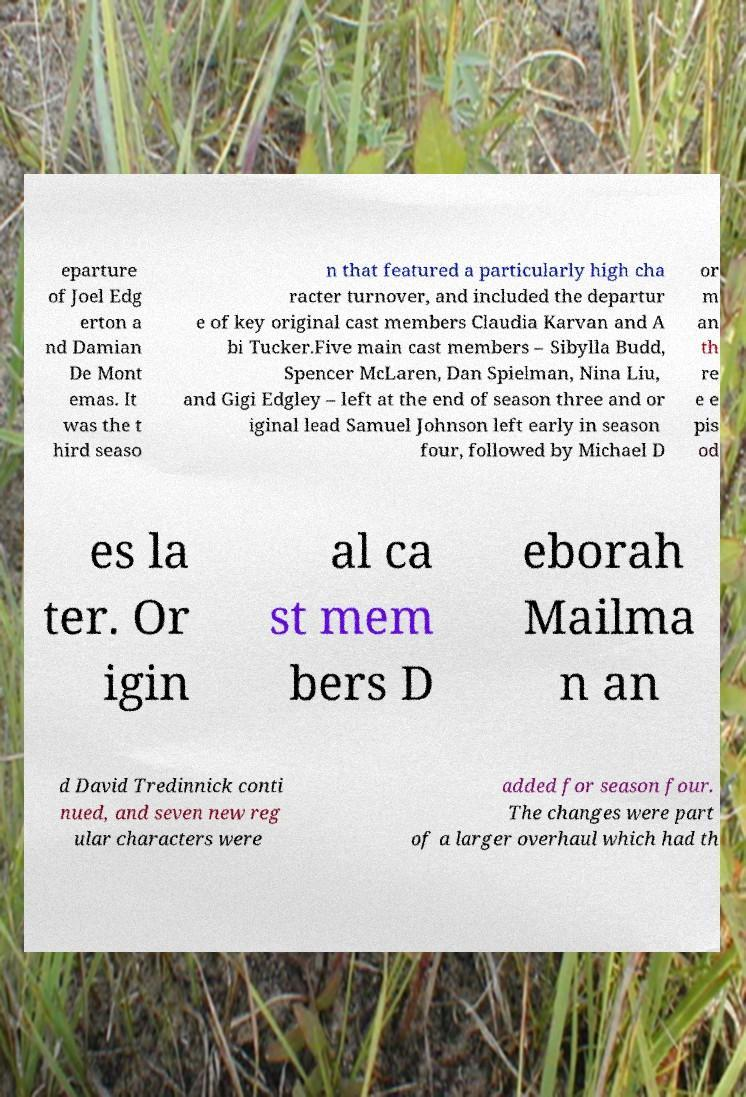There's text embedded in this image that I need extracted. Can you transcribe it verbatim? eparture of Joel Edg erton a nd Damian De Mont emas. It was the t hird seaso n that featured a particularly high cha racter turnover, and included the departur e of key original cast members Claudia Karvan and A bi Tucker.Five main cast members – Sibylla Budd, Spencer McLaren, Dan Spielman, Nina Liu, and Gigi Edgley – left at the end of season three and or iginal lead Samuel Johnson left early in season four, followed by Michael D or m an th re e e pis od es la ter. Or igin al ca st mem bers D eborah Mailma n an d David Tredinnick conti nued, and seven new reg ular characters were added for season four. The changes were part of a larger overhaul which had th 